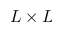<formula> <loc_0><loc_0><loc_500><loc_500>L \times L</formula> 